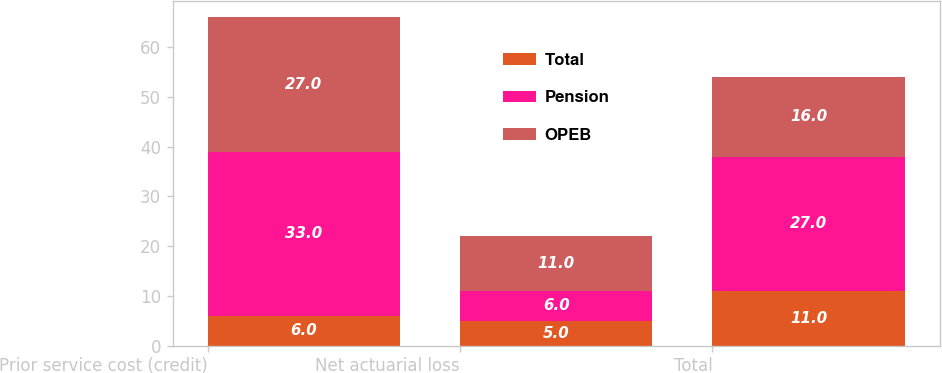Convert chart. <chart><loc_0><loc_0><loc_500><loc_500><stacked_bar_chart><ecel><fcel>Prior service cost (credit)<fcel>Net actuarial loss<fcel>Total<nl><fcel>Total<fcel>6<fcel>5<fcel>11<nl><fcel>Pension<fcel>33<fcel>6<fcel>27<nl><fcel>OPEB<fcel>27<fcel>11<fcel>16<nl></chart> 